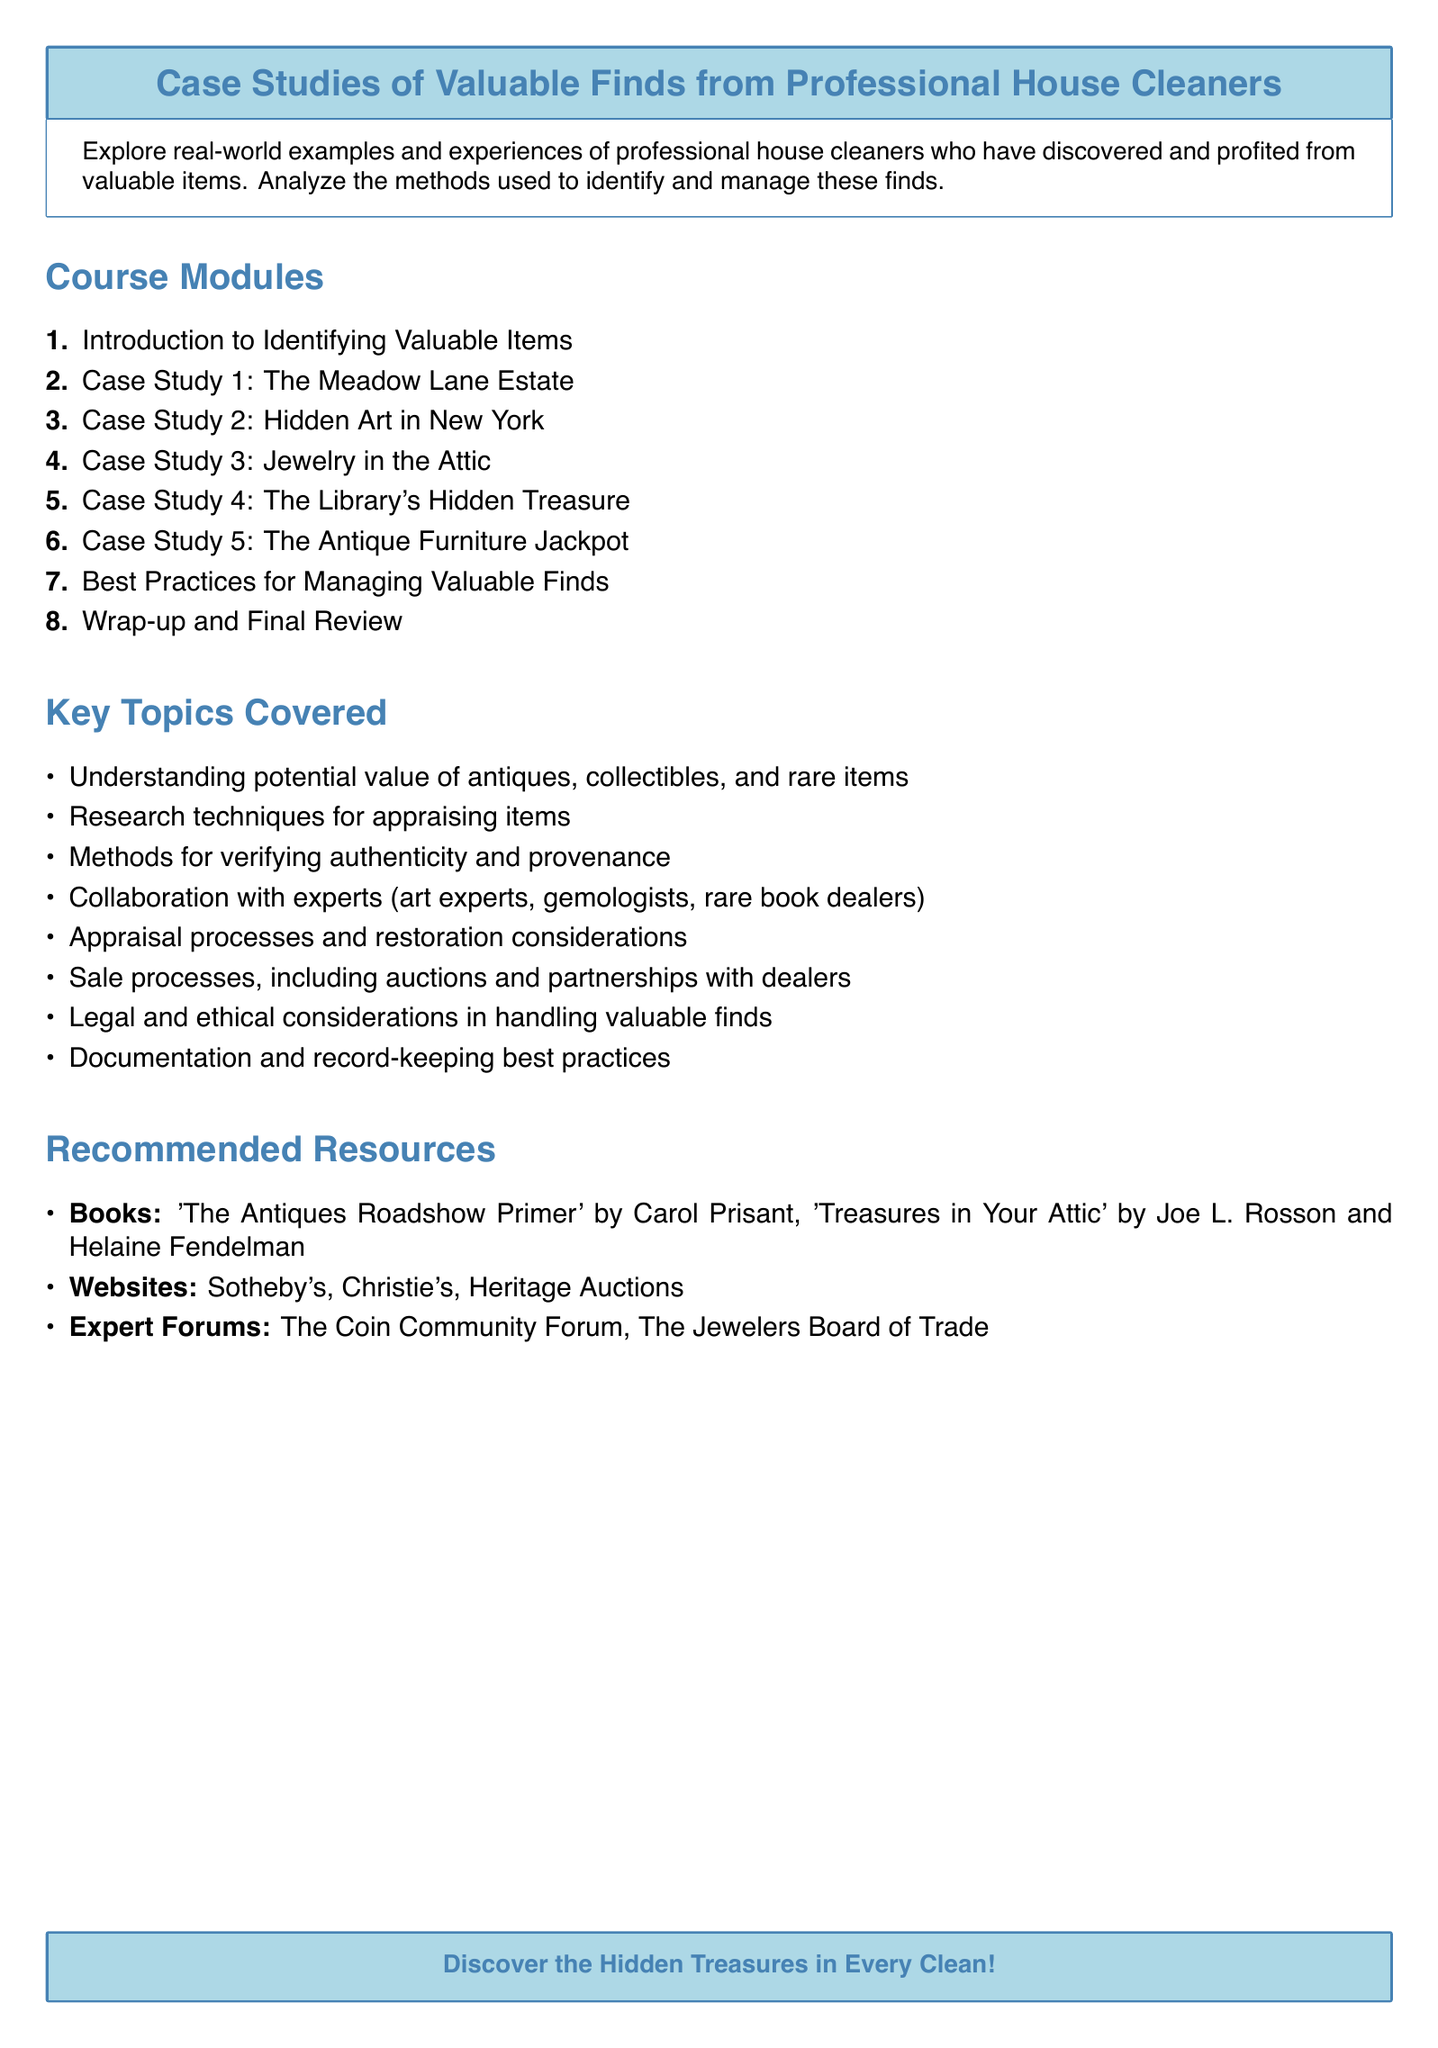what is the title of the syllabus? The title of the syllabus is clearly stated at the top of the document.
Answer: Case Studies of Valuable Finds from Professional House Cleaners how many case studies are included in the syllabus? The number of case studies is indicated in the course modules section.
Answer: 5 what is the focus of the course? The focus of the course is succinctly described in the brief overview section of the document.
Answer: Real-world examples and experiences who is the author of the recommended book "The Antiques Roadshow Primer"? The author is mentioned in the recommended resources section.
Answer: Carol Prisant what is the primary topic of the first module? The topic is listed in the course modules section.
Answer: Introduction to Identifying Valuable Items which topic includes collaboration with experts? The specific topic is identified in the key topics covered section.
Answer: Collaboration with experts what is the color theme of the syllabus? The color theme is evident throughout the document and indicated in the design choices.
Answer: Light blue and cleaner blue how many recommended resource types are there? The types of resources are listed in the recommended resources section.
Answer: 3 